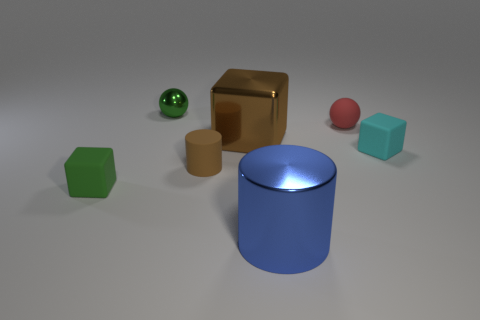Are the green thing behind the tiny cyan cube and the tiny sphere to the right of the large blue metallic cylinder made of the same material?
Provide a succinct answer. No. What number of other rubber objects are the same shape as the green matte object?
Provide a succinct answer. 1. Are there more small cyan things on the right side of the tiny red rubber sphere than tiny cubes that are behind the cyan object?
Provide a short and direct response. Yes. What color is the small sphere that is to the left of the tiny brown rubber cylinder that is on the left side of the small matte cube right of the tiny green matte block?
Your response must be concise. Green. There is a block to the left of the big brown shiny block; is its color the same as the tiny metal thing?
Provide a succinct answer. Yes. What number of other things are there of the same color as the metal block?
Keep it short and to the point. 1. How many things are either brown cylinders or large cubes?
Keep it short and to the point. 2. What number of objects are tiny brown spheres or small things left of the green shiny ball?
Keep it short and to the point. 1. Is the red thing made of the same material as the small cyan object?
Make the answer very short. Yes. What number of other objects are the same material as the large blue object?
Your response must be concise. 2. 